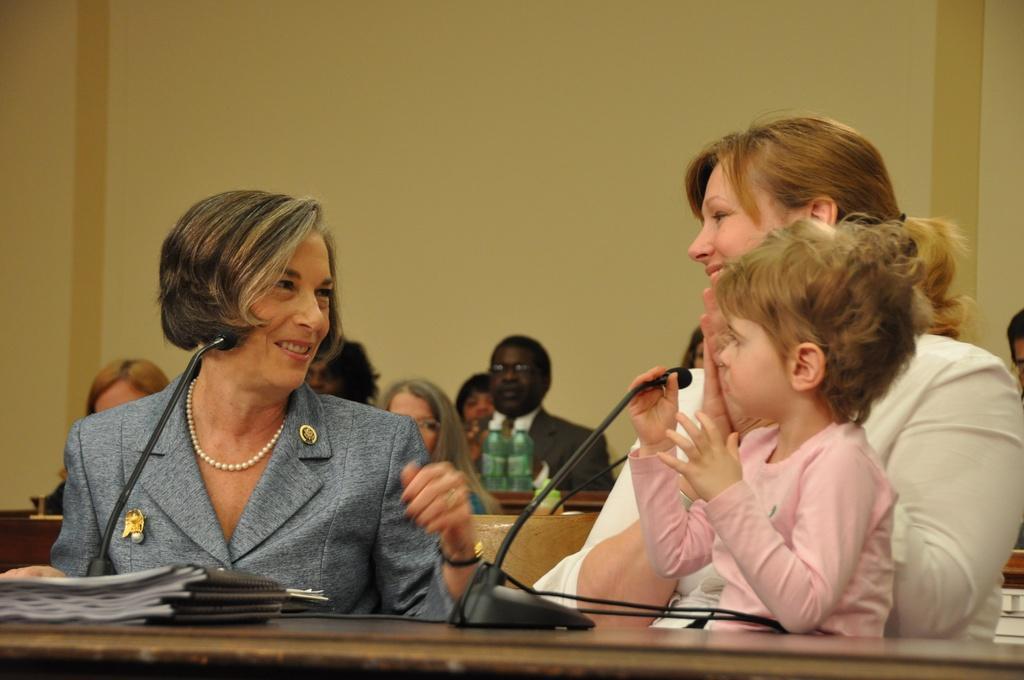Can you describe this image briefly? In this picture we have two women sitting and smiling at each other. They have a microphone In front of them. 